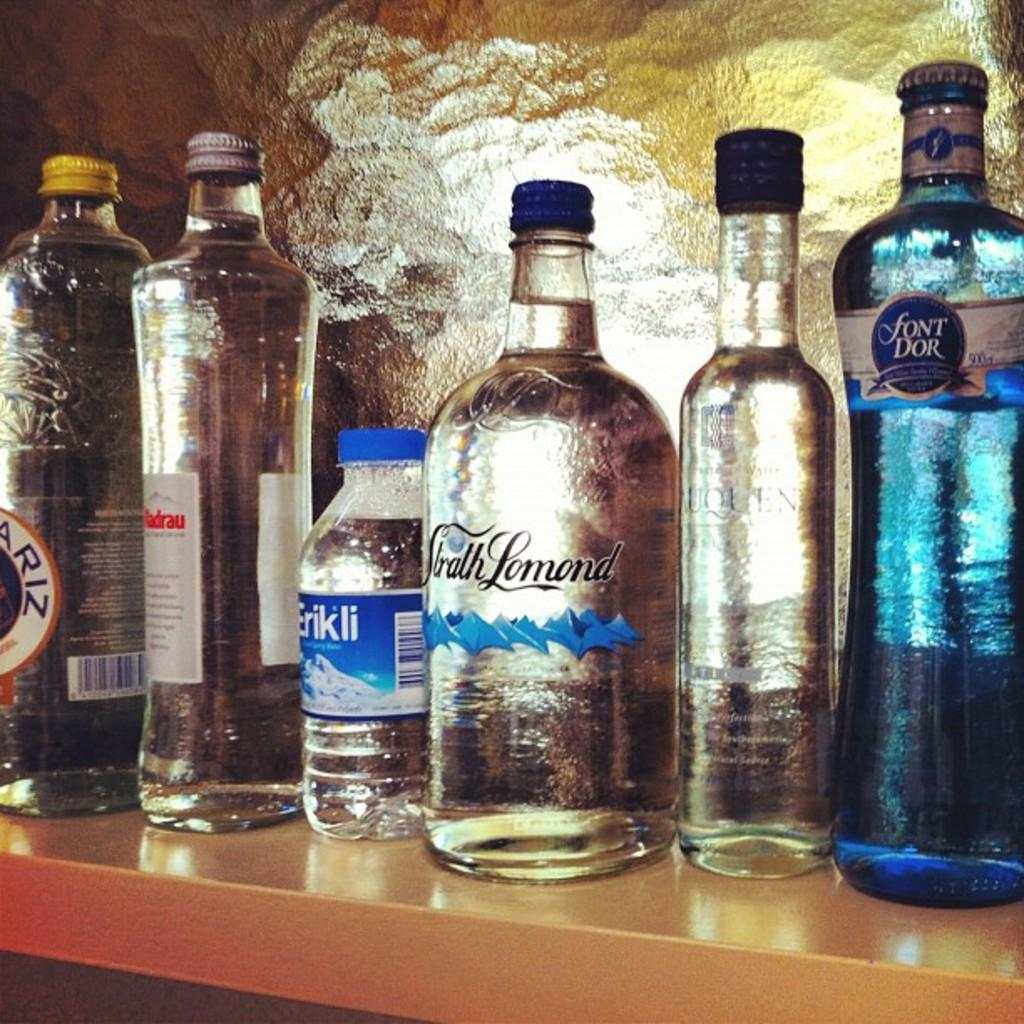What is the main subject of the image? The main subject of the image is a group of bottles. What is inside the bottles? The bottles contain syrup. How can we identify the type of syrup in each bottle? The bottles have labels that indicate the type of syrup. How are the bottles sealed? The bottles have lids to keep the syrup contained. How are the bottles arranged in the image? The bottles are placed in a rack in an order. What can be seen in the background of the image? There is a wall in the background of the image. Can you tell me how many fish are swimming in the bottles in the image? There are no fish present in the image; the bottles contain syrup. What type of pump is used to dispense the syrup from the bottles in the image? There is no pump visible in the image; the bottles have lids to keep the syrup contained. 